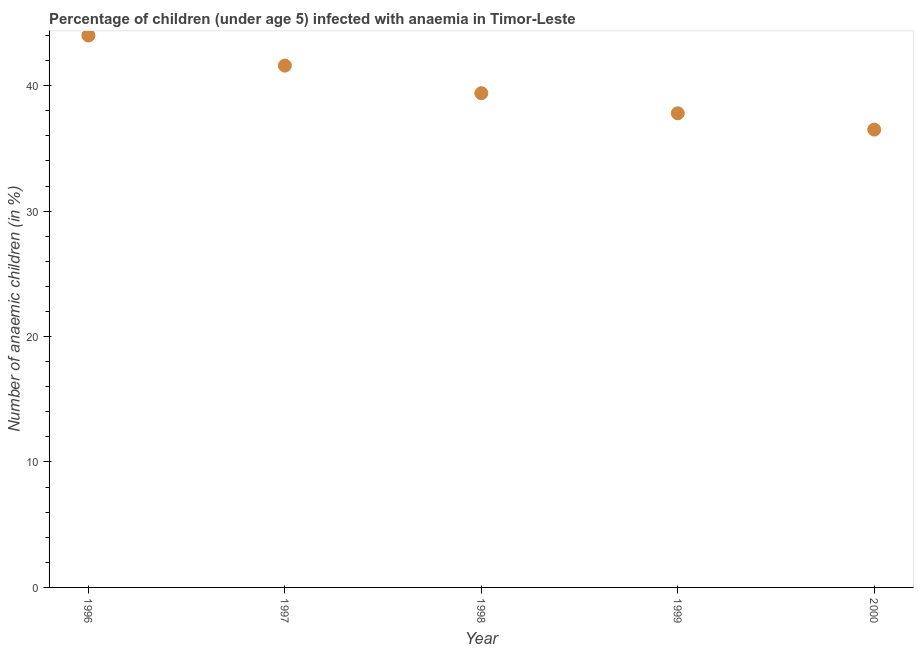What is the number of anaemic children in 2000?
Your answer should be very brief. 36.5. Across all years, what is the maximum number of anaemic children?
Your answer should be very brief. 44. Across all years, what is the minimum number of anaemic children?
Your answer should be very brief. 36.5. What is the sum of the number of anaemic children?
Make the answer very short. 199.3. What is the difference between the number of anaemic children in 1999 and 2000?
Provide a short and direct response. 1.3. What is the average number of anaemic children per year?
Your response must be concise. 39.86. What is the median number of anaemic children?
Your answer should be very brief. 39.4. Do a majority of the years between 1997 and 1998 (inclusive) have number of anaemic children greater than 2 %?
Your response must be concise. Yes. What is the ratio of the number of anaemic children in 1996 to that in 1998?
Give a very brief answer. 1.12. What is the difference between the highest and the second highest number of anaemic children?
Keep it short and to the point. 2.4. What is the difference between the highest and the lowest number of anaemic children?
Keep it short and to the point. 7.5. In how many years, is the number of anaemic children greater than the average number of anaemic children taken over all years?
Your response must be concise. 2. How many dotlines are there?
Your answer should be very brief. 1. What is the difference between two consecutive major ticks on the Y-axis?
Your response must be concise. 10. Are the values on the major ticks of Y-axis written in scientific E-notation?
Offer a terse response. No. What is the title of the graph?
Your answer should be very brief. Percentage of children (under age 5) infected with anaemia in Timor-Leste. What is the label or title of the Y-axis?
Your answer should be compact. Number of anaemic children (in %). What is the Number of anaemic children (in %) in 1996?
Offer a very short reply. 44. What is the Number of anaemic children (in %) in 1997?
Ensure brevity in your answer.  41.6. What is the Number of anaemic children (in %) in 1998?
Provide a short and direct response. 39.4. What is the Number of anaemic children (in %) in 1999?
Provide a succinct answer. 37.8. What is the Number of anaemic children (in %) in 2000?
Offer a very short reply. 36.5. What is the difference between the Number of anaemic children (in %) in 1998 and 2000?
Offer a very short reply. 2.9. What is the ratio of the Number of anaemic children (in %) in 1996 to that in 1997?
Provide a short and direct response. 1.06. What is the ratio of the Number of anaemic children (in %) in 1996 to that in 1998?
Keep it short and to the point. 1.12. What is the ratio of the Number of anaemic children (in %) in 1996 to that in 1999?
Your answer should be very brief. 1.16. What is the ratio of the Number of anaemic children (in %) in 1996 to that in 2000?
Give a very brief answer. 1.21. What is the ratio of the Number of anaemic children (in %) in 1997 to that in 1998?
Ensure brevity in your answer.  1.06. What is the ratio of the Number of anaemic children (in %) in 1997 to that in 1999?
Provide a succinct answer. 1.1. What is the ratio of the Number of anaemic children (in %) in 1997 to that in 2000?
Make the answer very short. 1.14. What is the ratio of the Number of anaemic children (in %) in 1998 to that in 1999?
Offer a very short reply. 1.04. What is the ratio of the Number of anaemic children (in %) in 1998 to that in 2000?
Offer a very short reply. 1.08. What is the ratio of the Number of anaemic children (in %) in 1999 to that in 2000?
Your response must be concise. 1.04. 